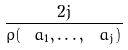Convert formula to latex. <formula><loc_0><loc_0><loc_500><loc_500>\frac { 2 j } { \rho ( \ a _ { 1 } , \dots , \ a _ { j } ) }</formula> 